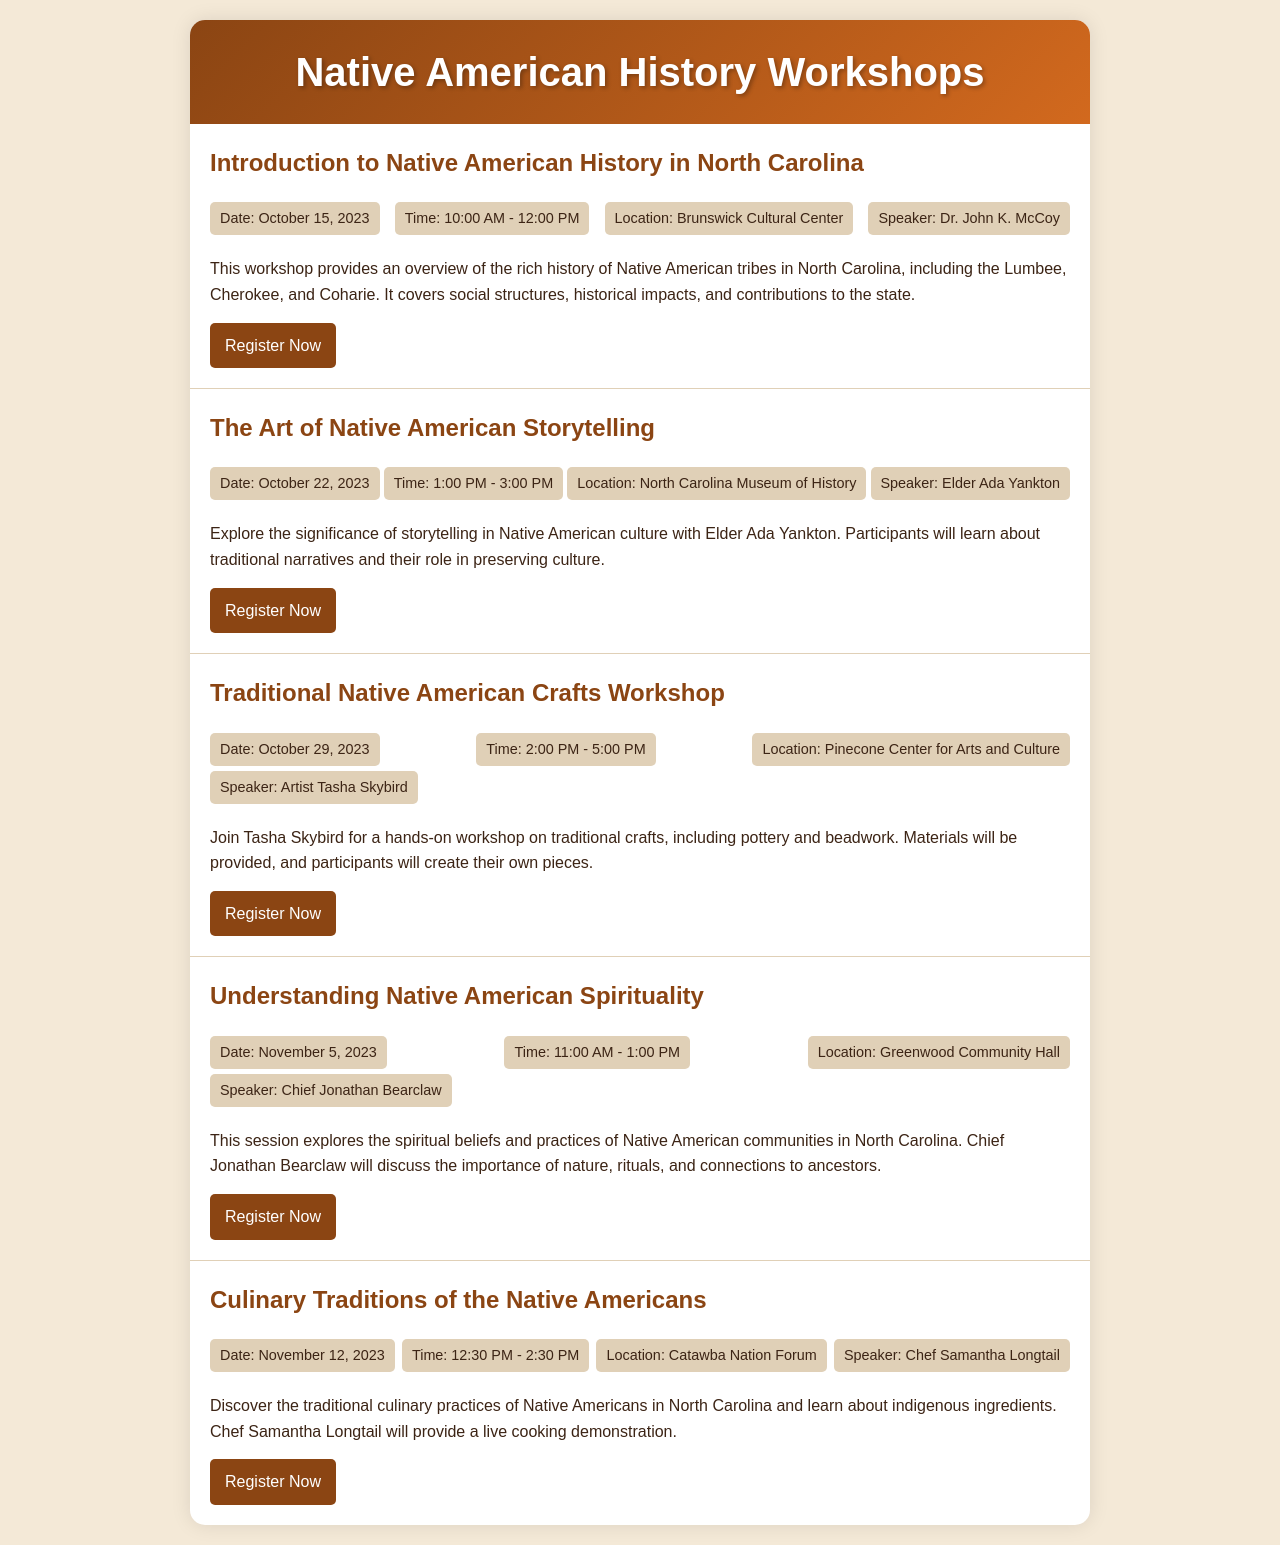What is the date of the first workshop? The date of the first workshop, "Introduction to Native American History in North Carolina," is mentioned in the document.
Answer: October 15, 2023 Who is the speaker for the storytelling workshop? The document lists Elder Ada Yankton as the speaker for "The Art of Native American Storytelling."
Answer: Elder Ada Yankton What is the location of the culinary traditions workshop? The document specifies the Catawba Nation Forum as the location for the "Culinary Traditions of the Native Americans" workshop.
Answer: Catawba Nation Forum What type of crafts will be covered in the third workshop? The description of "Traditional Native American Crafts Workshop" indicates the crafts that will be covered include pottery and beadwork.
Answer: Pottery and beadwork How many workshops are scheduled in total? The document outlines five workshops, each with its specific details.
Answer: Five What is the time of the workshop on November 5, 2023? The document provides the time for "Understanding Native American Spirituality" as 11:00 AM - 1:00 PM.
Answer: 11:00 AM - 1:00 PM Who will provide a live cooking demonstration? The name of the speaker for the cooking demonstration workshop, Chef Samantha Longtail, is found in the document.
Answer: Chef Samantha Longtail What is the focus of the workshop conducted by Chief Jonathan Bearclaw? The explanation in the document states that the focus is on the spiritual beliefs and practices of Native American communities.
Answer: Spiritual beliefs and practices What is the registration link for the traditional crafts workshop? The document provides a specific URL for participants to register for the "Traditional Native American Crafts Workshop."
Answer: http://www.ncartsandcrafts.org 